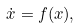<formula> <loc_0><loc_0><loc_500><loc_500>\dot { x } = f ( x ) ,</formula> 